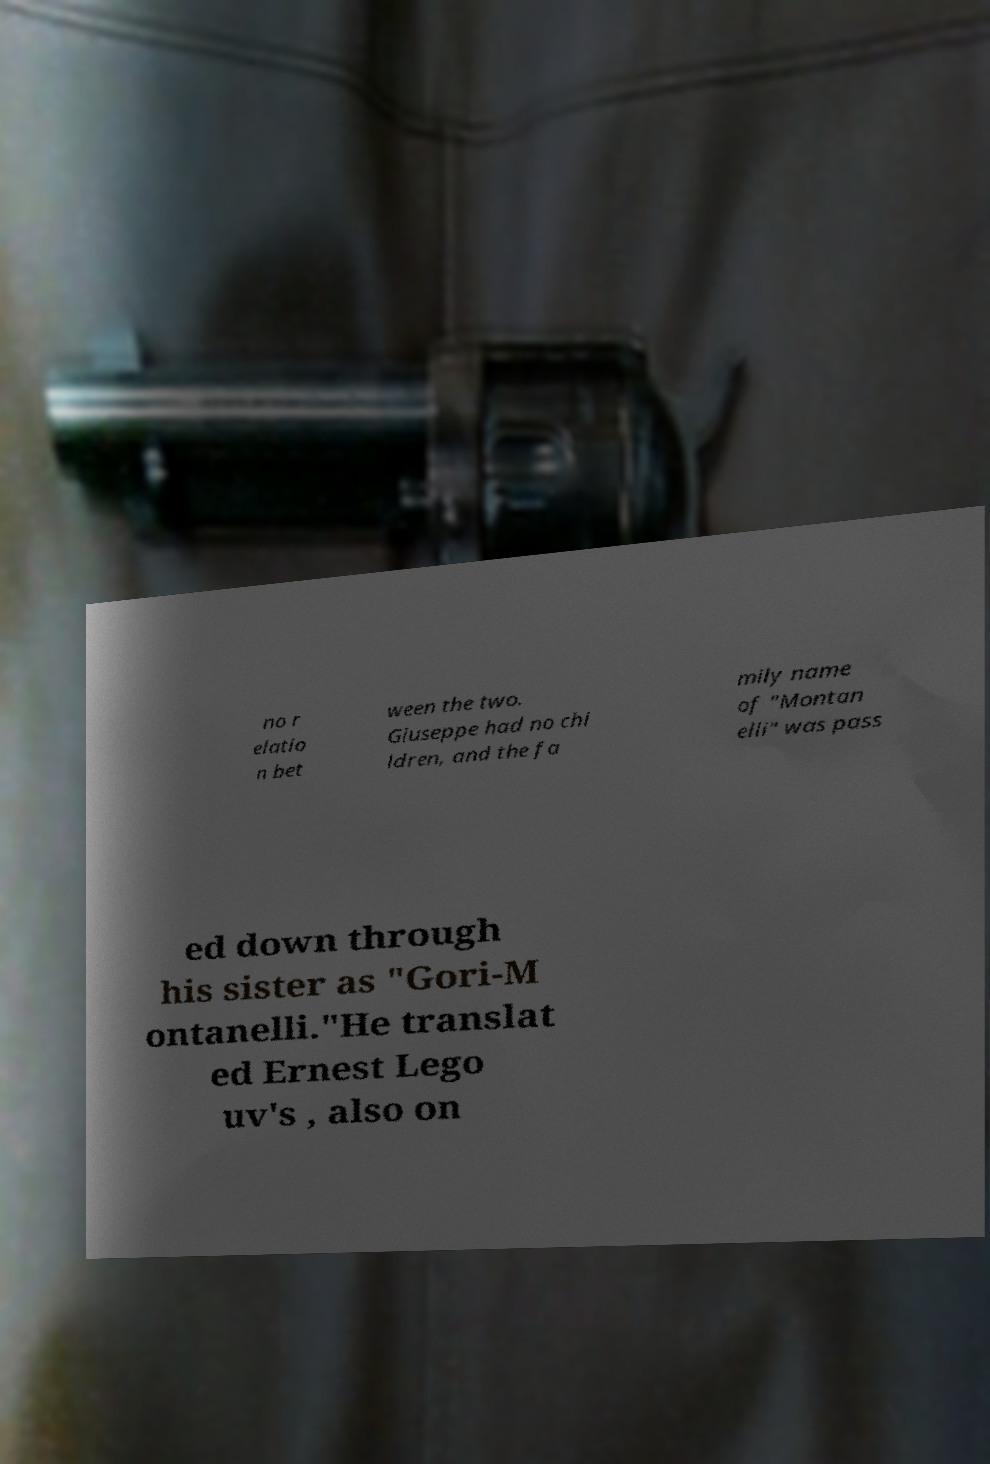What messages or text are displayed in this image? I need them in a readable, typed format. no r elatio n bet ween the two. Giuseppe had no chi ldren, and the fa mily name of "Montan elli" was pass ed down through his sister as "Gori-M ontanelli."He translat ed Ernest Lego uv's , also on 